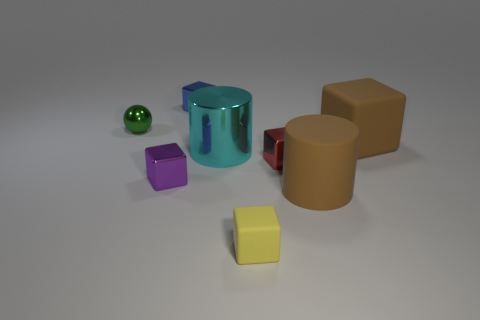Subtract all large brown rubber blocks. How many blocks are left? 4 Subtract all purple cubes. How many cubes are left? 4 Subtract all cyan blocks. Subtract all gray spheres. How many blocks are left? 5 Add 2 tiny purple metallic things. How many objects exist? 10 Subtract all cylinders. How many objects are left? 6 Add 3 large cyan cylinders. How many large cyan cylinders are left? 4 Add 3 metallic blocks. How many metallic blocks exist? 6 Subtract 0 gray blocks. How many objects are left? 8 Subtract all small brown metallic spheres. Subtract all green balls. How many objects are left? 7 